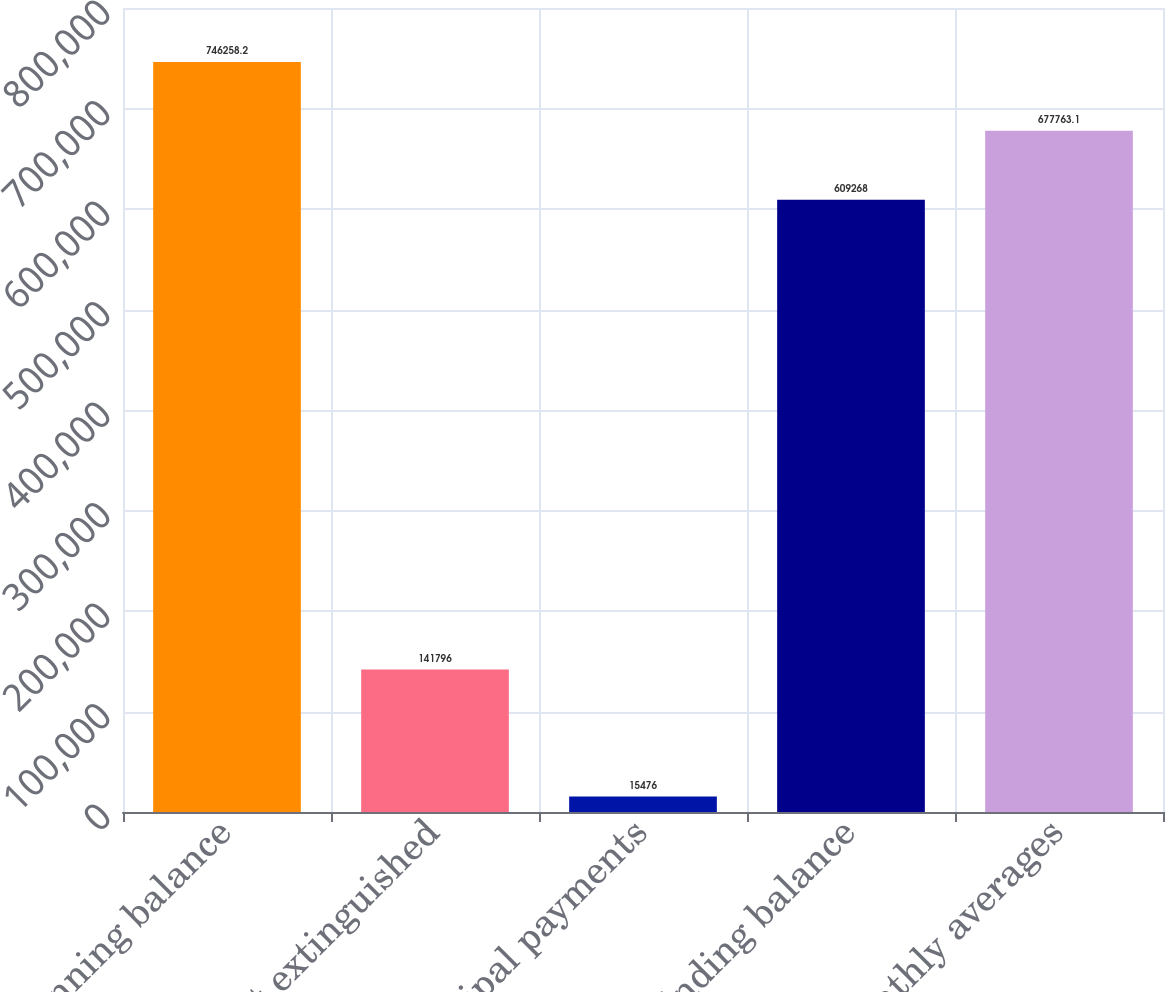Convert chart. <chart><loc_0><loc_0><loc_500><loc_500><bar_chart><fcel>Beginning balance<fcel>Debt extinguished<fcel>Principal payments<fcel>Ending balance<fcel>Monthly averages<nl><fcel>746258<fcel>141796<fcel>15476<fcel>609268<fcel>677763<nl></chart> 